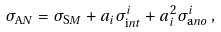Convert formula to latex. <formula><loc_0><loc_0><loc_500><loc_500>\sigma _ { \text  AN} = \sigma_{\text  SM} + a_{i} \sigma_{\text  int}^{i} + a_{i}^{2} \sigma_{\text  ano}^{i} \, ,</formula> 